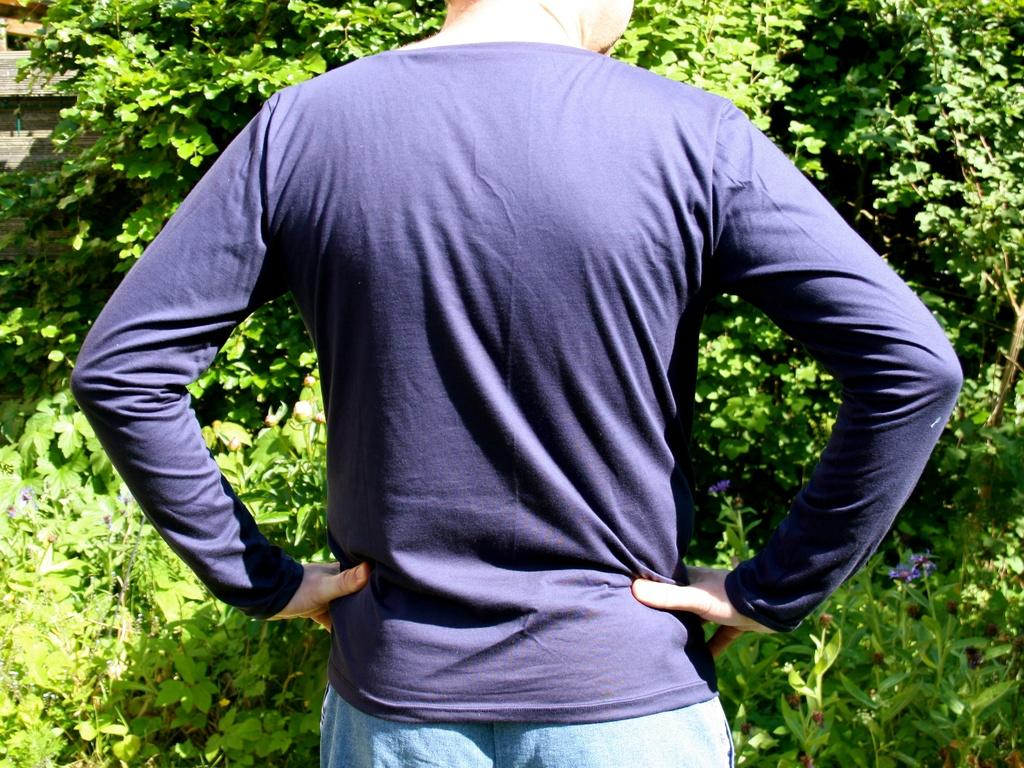What is the main subject of the image? There is a person standing in the image. Where is the person standing? The person is standing on the ground. What can be seen in the background of the image? There are trees and a building in the background of the image. What is the weather like in the image? The image appears to have been taken on a sunny day. What type of truck is parked next to the person in the image? There is no truck present in the image; it only features a person standing on the ground with trees and a building in the background. 